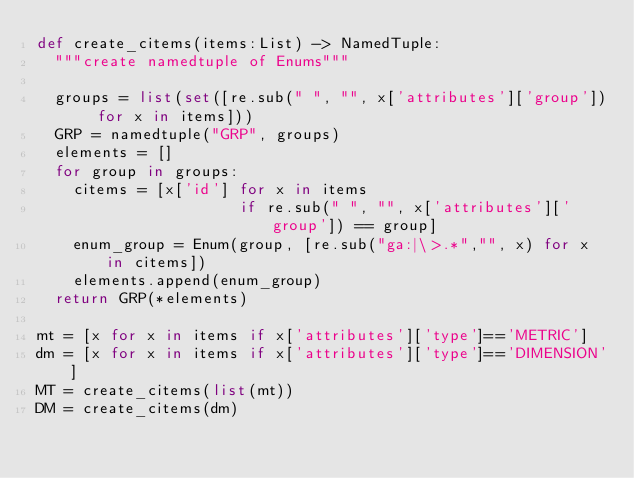<code> <loc_0><loc_0><loc_500><loc_500><_Python_>def create_citems(items:List) -> NamedTuple:
  """create namedtuple of Enums"""

  groups = list(set([re.sub(" ", "", x['attributes']['group']) for x in items]))
  GRP = namedtuple("GRP", groups)
  elements = []
  for group in groups:
    citems = [x['id'] for x in items 
                      if re.sub(" ", "", x['attributes']['group']) == group]    
    enum_group = Enum(group, [re.sub("ga:|\>.*","", x) for x in citems])
    elements.append(enum_group)
  return GRP(*elements)

mt = [x for x in items if x['attributes']['type']=='METRIC']
dm = [x for x in items if x['attributes']['type']=='DIMENSION']
MT = create_citems(list(mt))
DM = create_citems(dm)

</code> 